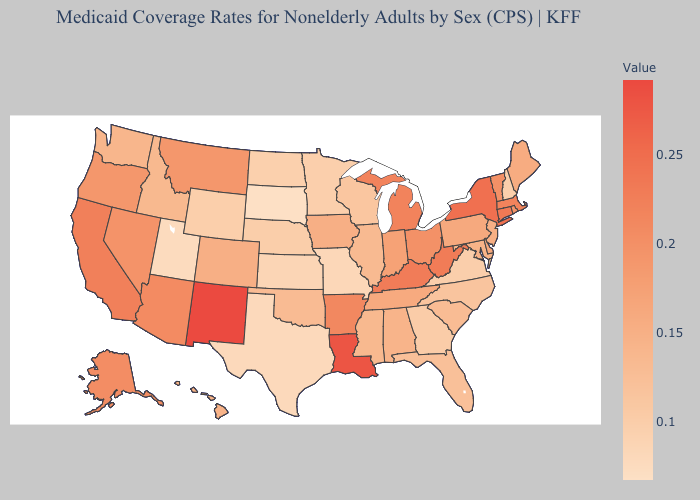Which states have the highest value in the USA?
Quick response, please. New Mexico. Among the states that border Tennessee , does Alabama have the lowest value?
Be succinct. No. Does Nebraska have a lower value than Indiana?
Short answer required. Yes. Does New Mexico have the highest value in the West?
Give a very brief answer. Yes. Among the states that border Arkansas , does Oklahoma have the lowest value?
Keep it brief. No. Does South Dakota have the lowest value in the USA?
Short answer required. Yes. Among the states that border New Hampshire , does Maine have the highest value?
Write a very short answer. No. 